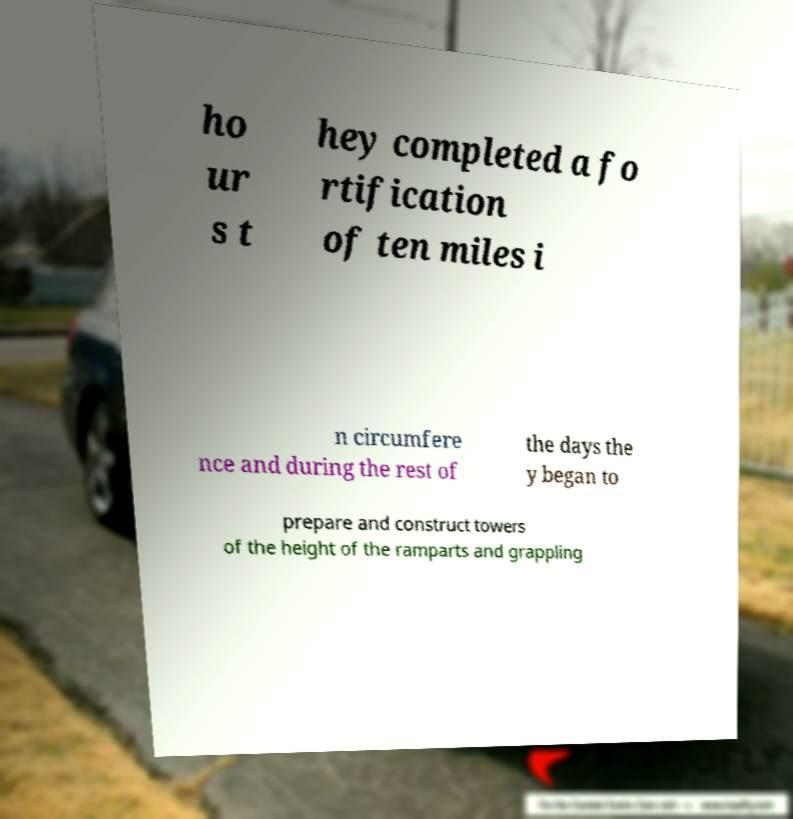Please identify and transcribe the text found in this image. ho ur s t hey completed a fo rtification of ten miles i n circumfere nce and during the rest of the days the y began to prepare and construct towers of the height of the ramparts and grappling 